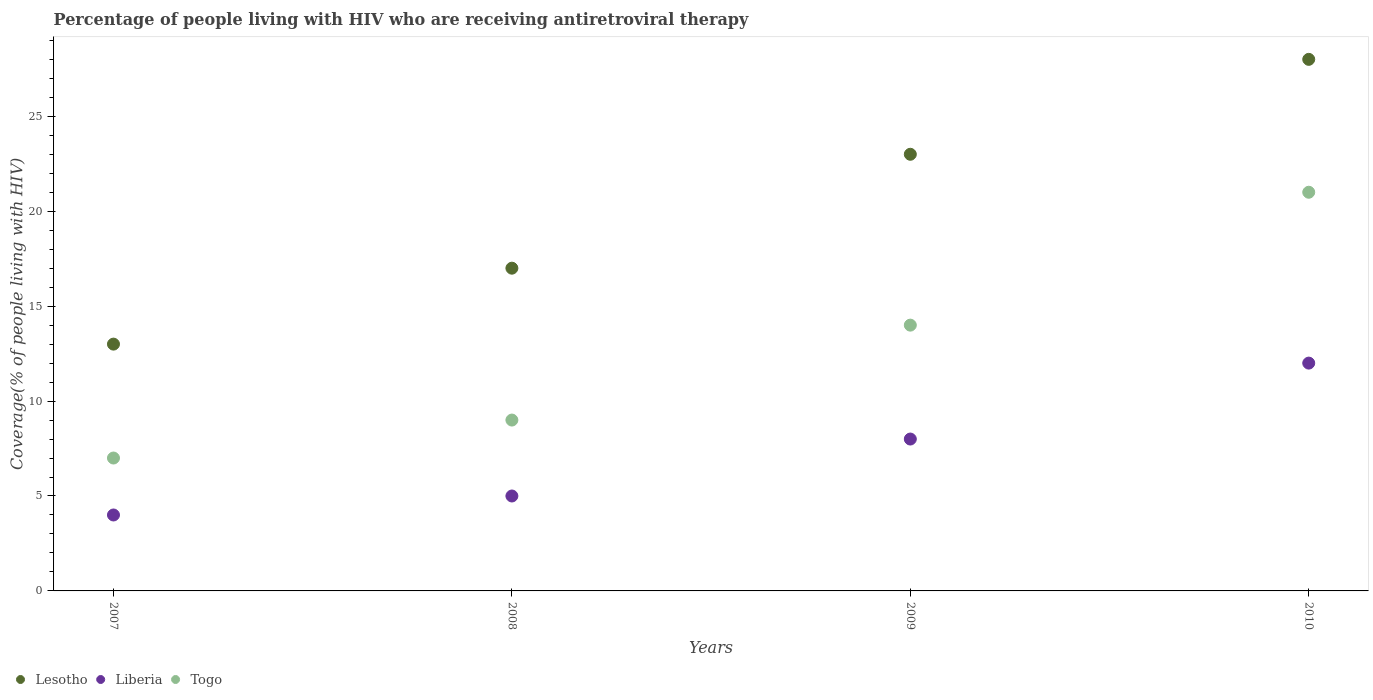How many different coloured dotlines are there?
Your answer should be compact. 3. Is the number of dotlines equal to the number of legend labels?
Offer a terse response. Yes. What is the percentage of the HIV infected people who are receiving antiretroviral therapy in Lesotho in 2008?
Give a very brief answer. 17. Across all years, what is the maximum percentage of the HIV infected people who are receiving antiretroviral therapy in Togo?
Your answer should be compact. 21. Across all years, what is the minimum percentage of the HIV infected people who are receiving antiretroviral therapy in Lesotho?
Ensure brevity in your answer.  13. What is the total percentage of the HIV infected people who are receiving antiretroviral therapy in Liberia in the graph?
Provide a succinct answer. 29. What is the difference between the percentage of the HIV infected people who are receiving antiretroviral therapy in Lesotho in 2007 and that in 2010?
Make the answer very short. -15. What is the difference between the percentage of the HIV infected people who are receiving antiretroviral therapy in Liberia in 2010 and the percentage of the HIV infected people who are receiving antiretroviral therapy in Lesotho in 2009?
Offer a terse response. -11. What is the average percentage of the HIV infected people who are receiving antiretroviral therapy in Togo per year?
Make the answer very short. 12.75. In the year 2009, what is the difference between the percentage of the HIV infected people who are receiving antiretroviral therapy in Lesotho and percentage of the HIV infected people who are receiving antiretroviral therapy in Liberia?
Your response must be concise. 15. In how many years, is the percentage of the HIV infected people who are receiving antiretroviral therapy in Togo greater than 17 %?
Your answer should be very brief. 1. What is the ratio of the percentage of the HIV infected people who are receiving antiretroviral therapy in Lesotho in 2008 to that in 2010?
Ensure brevity in your answer.  0.61. Is the difference between the percentage of the HIV infected people who are receiving antiretroviral therapy in Lesotho in 2007 and 2010 greater than the difference between the percentage of the HIV infected people who are receiving antiretroviral therapy in Liberia in 2007 and 2010?
Your response must be concise. No. What is the difference between the highest and the lowest percentage of the HIV infected people who are receiving antiretroviral therapy in Togo?
Your response must be concise. 14. Is it the case that in every year, the sum of the percentage of the HIV infected people who are receiving antiretroviral therapy in Togo and percentage of the HIV infected people who are receiving antiretroviral therapy in Liberia  is greater than the percentage of the HIV infected people who are receiving antiretroviral therapy in Lesotho?
Your answer should be very brief. No. Does the percentage of the HIV infected people who are receiving antiretroviral therapy in Togo monotonically increase over the years?
Offer a very short reply. Yes. How many dotlines are there?
Offer a very short reply. 3. Does the graph contain grids?
Your response must be concise. No. Where does the legend appear in the graph?
Your response must be concise. Bottom left. How are the legend labels stacked?
Ensure brevity in your answer.  Horizontal. What is the title of the graph?
Provide a short and direct response. Percentage of people living with HIV who are receiving antiretroviral therapy. What is the label or title of the X-axis?
Your answer should be very brief. Years. What is the label or title of the Y-axis?
Your response must be concise. Coverage(% of people living with HIV). What is the Coverage(% of people living with HIV) in Liberia in 2007?
Keep it short and to the point. 4. What is the Coverage(% of people living with HIV) in Togo in 2007?
Offer a very short reply. 7. What is the Coverage(% of people living with HIV) of Togo in 2008?
Make the answer very short. 9. What is the Coverage(% of people living with HIV) of Liberia in 2009?
Provide a succinct answer. 8. Across all years, what is the maximum Coverage(% of people living with HIV) in Liberia?
Keep it short and to the point. 12. Across all years, what is the minimum Coverage(% of people living with HIV) in Lesotho?
Keep it short and to the point. 13. Across all years, what is the minimum Coverage(% of people living with HIV) in Togo?
Offer a terse response. 7. What is the total Coverage(% of people living with HIV) in Lesotho in the graph?
Offer a terse response. 81. What is the difference between the Coverage(% of people living with HIV) of Lesotho in 2007 and that in 2008?
Make the answer very short. -4. What is the difference between the Coverage(% of people living with HIV) of Liberia in 2007 and that in 2008?
Provide a short and direct response. -1. What is the difference between the Coverage(% of people living with HIV) of Togo in 2007 and that in 2008?
Your answer should be compact. -2. What is the difference between the Coverage(% of people living with HIV) of Lesotho in 2007 and that in 2010?
Offer a very short reply. -15. What is the difference between the Coverage(% of people living with HIV) of Togo in 2007 and that in 2010?
Your response must be concise. -14. What is the difference between the Coverage(% of people living with HIV) in Lesotho in 2008 and that in 2009?
Offer a very short reply. -6. What is the difference between the Coverage(% of people living with HIV) in Liberia in 2008 and that in 2009?
Offer a very short reply. -3. What is the difference between the Coverage(% of people living with HIV) in Togo in 2008 and that in 2010?
Provide a short and direct response. -12. What is the difference between the Coverage(% of people living with HIV) in Lesotho in 2009 and that in 2010?
Provide a short and direct response. -5. What is the difference between the Coverage(% of people living with HIV) in Liberia in 2009 and that in 2010?
Give a very brief answer. -4. What is the difference between the Coverage(% of people living with HIV) in Togo in 2009 and that in 2010?
Give a very brief answer. -7. What is the difference between the Coverage(% of people living with HIV) in Lesotho in 2007 and the Coverage(% of people living with HIV) in Liberia in 2008?
Offer a terse response. 8. What is the difference between the Coverage(% of people living with HIV) of Lesotho in 2007 and the Coverage(% of people living with HIV) of Togo in 2009?
Provide a short and direct response. -1. What is the difference between the Coverage(% of people living with HIV) in Liberia in 2007 and the Coverage(% of people living with HIV) in Togo in 2009?
Give a very brief answer. -10. What is the difference between the Coverage(% of people living with HIV) of Lesotho in 2007 and the Coverage(% of people living with HIV) of Togo in 2010?
Provide a short and direct response. -8. What is the difference between the Coverage(% of people living with HIV) of Lesotho in 2008 and the Coverage(% of people living with HIV) of Liberia in 2009?
Keep it short and to the point. 9. What is the difference between the Coverage(% of people living with HIV) in Liberia in 2008 and the Coverage(% of people living with HIV) in Togo in 2010?
Keep it short and to the point. -16. What is the difference between the Coverage(% of people living with HIV) of Lesotho in 2009 and the Coverage(% of people living with HIV) of Togo in 2010?
Your response must be concise. 2. What is the average Coverage(% of people living with HIV) in Lesotho per year?
Ensure brevity in your answer.  20.25. What is the average Coverage(% of people living with HIV) of Liberia per year?
Keep it short and to the point. 7.25. What is the average Coverage(% of people living with HIV) in Togo per year?
Give a very brief answer. 12.75. In the year 2007, what is the difference between the Coverage(% of people living with HIV) of Lesotho and Coverage(% of people living with HIV) of Togo?
Make the answer very short. 6. In the year 2008, what is the difference between the Coverage(% of people living with HIV) of Lesotho and Coverage(% of people living with HIV) of Liberia?
Your response must be concise. 12. In the year 2009, what is the difference between the Coverage(% of people living with HIV) of Lesotho and Coverage(% of people living with HIV) of Liberia?
Ensure brevity in your answer.  15. In the year 2010, what is the difference between the Coverage(% of people living with HIV) of Lesotho and Coverage(% of people living with HIV) of Liberia?
Your answer should be compact. 16. In the year 2010, what is the difference between the Coverage(% of people living with HIV) of Lesotho and Coverage(% of people living with HIV) of Togo?
Your response must be concise. 7. In the year 2010, what is the difference between the Coverage(% of people living with HIV) in Liberia and Coverage(% of people living with HIV) in Togo?
Your answer should be compact. -9. What is the ratio of the Coverage(% of people living with HIV) of Lesotho in 2007 to that in 2008?
Provide a succinct answer. 0.76. What is the ratio of the Coverage(% of people living with HIV) of Liberia in 2007 to that in 2008?
Provide a succinct answer. 0.8. What is the ratio of the Coverage(% of people living with HIV) of Togo in 2007 to that in 2008?
Provide a succinct answer. 0.78. What is the ratio of the Coverage(% of people living with HIV) in Lesotho in 2007 to that in 2009?
Give a very brief answer. 0.57. What is the ratio of the Coverage(% of people living with HIV) in Liberia in 2007 to that in 2009?
Provide a succinct answer. 0.5. What is the ratio of the Coverage(% of people living with HIV) in Lesotho in 2007 to that in 2010?
Ensure brevity in your answer.  0.46. What is the ratio of the Coverage(% of people living with HIV) of Liberia in 2007 to that in 2010?
Your answer should be very brief. 0.33. What is the ratio of the Coverage(% of people living with HIV) in Togo in 2007 to that in 2010?
Provide a short and direct response. 0.33. What is the ratio of the Coverage(% of people living with HIV) in Lesotho in 2008 to that in 2009?
Provide a succinct answer. 0.74. What is the ratio of the Coverage(% of people living with HIV) in Liberia in 2008 to that in 2009?
Ensure brevity in your answer.  0.62. What is the ratio of the Coverage(% of people living with HIV) in Togo in 2008 to that in 2009?
Your answer should be very brief. 0.64. What is the ratio of the Coverage(% of people living with HIV) of Lesotho in 2008 to that in 2010?
Provide a succinct answer. 0.61. What is the ratio of the Coverage(% of people living with HIV) in Liberia in 2008 to that in 2010?
Make the answer very short. 0.42. What is the ratio of the Coverage(% of people living with HIV) in Togo in 2008 to that in 2010?
Provide a succinct answer. 0.43. What is the ratio of the Coverage(% of people living with HIV) in Lesotho in 2009 to that in 2010?
Provide a short and direct response. 0.82. What is the difference between the highest and the second highest Coverage(% of people living with HIV) in Liberia?
Make the answer very short. 4. What is the difference between the highest and the lowest Coverage(% of people living with HIV) of Togo?
Make the answer very short. 14. 